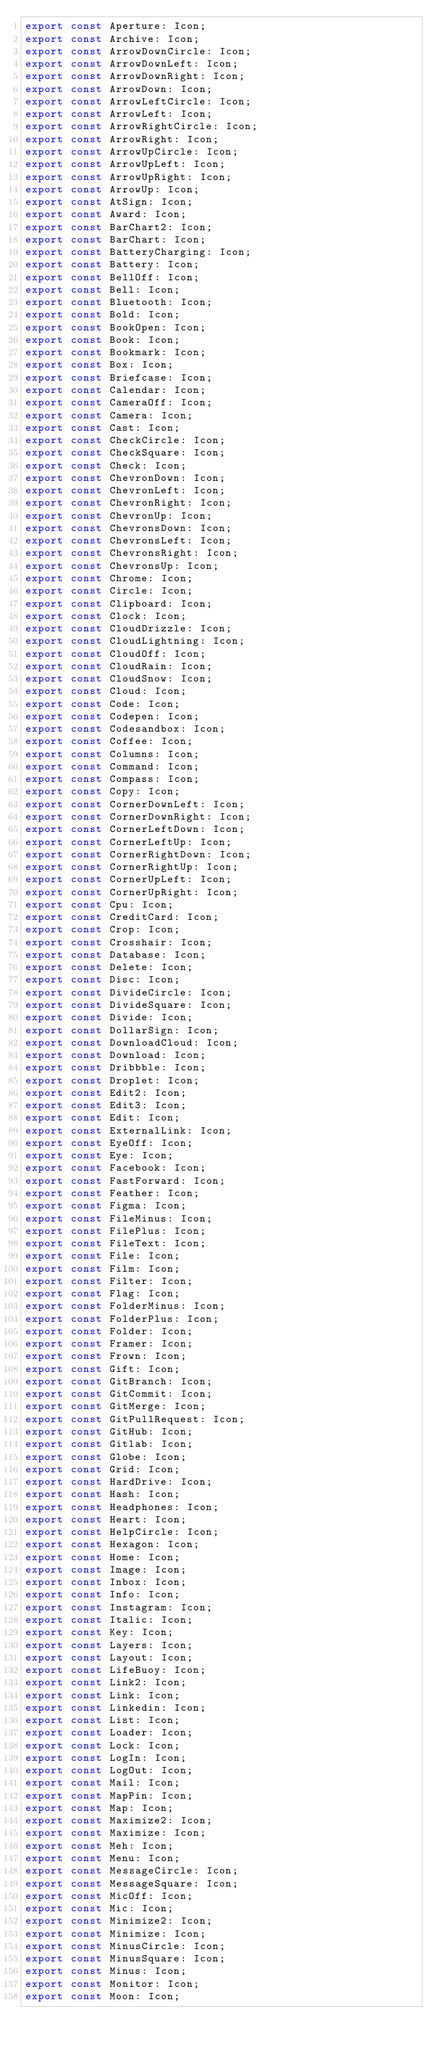<code> <loc_0><loc_0><loc_500><loc_500><_TypeScript_>export const Aperture: Icon;
export const Archive: Icon;
export const ArrowDownCircle: Icon;
export const ArrowDownLeft: Icon;
export const ArrowDownRight: Icon;
export const ArrowDown: Icon;
export const ArrowLeftCircle: Icon;
export const ArrowLeft: Icon;
export const ArrowRightCircle: Icon;
export const ArrowRight: Icon;
export const ArrowUpCircle: Icon;
export const ArrowUpLeft: Icon;
export const ArrowUpRight: Icon;
export const ArrowUp: Icon;
export const AtSign: Icon;
export const Award: Icon;
export const BarChart2: Icon;
export const BarChart: Icon;
export const BatteryCharging: Icon;
export const Battery: Icon;
export const BellOff: Icon;
export const Bell: Icon;
export const Bluetooth: Icon;
export const Bold: Icon;
export const BookOpen: Icon;
export const Book: Icon;
export const Bookmark: Icon;
export const Box: Icon;
export const Briefcase: Icon;
export const Calendar: Icon;
export const CameraOff: Icon;
export const Camera: Icon;
export const Cast: Icon;
export const CheckCircle: Icon;
export const CheckSquare: Icon;
export const Check: Icon;
export const ChevronDown: Icon;
export const ChevronLeft: Icon;
export const ChevronRight: Icon;
export const ChevronUp: Icon;
export const ChevronsDown: Icon;
export const ChevronsLeft: Icon;
export const ChevronsRight: Icon;
export const ChevronsUp: Icon;
export const Chrome: Icon;
export const Circle: Icon;
export const Clipboard: Icon;
export const Clock: Icon;
export const CloudDrizzle: Icon;
export const CloudLightning: Icon;
export const CloudOff: Icon;
export const CloudRain: Icon;
export const CloudSnow: Icon;
export const Cloud: Icon;
export const Code: Icon;
export const Codepen: Icon;
export const Codesandbox: Icon;
export const Coffee: Icon;
export const Columns: Icon;
export const Command: Icon;
export const Compass: Icon;
export const Copy: Icon;
export const CornerDownLeft: Icon;
export const CornerDownRight: Icon;
export const CornerLeftDown: Icon;
export const CornerLeftUp: Icon;
export const CornerRightDown: Icon;
export const CornerRightUp: Icon;
export const CornerUpLeft: Icon;
export const CornerUpRight: Icon;
export const Cpu: Icon;
export const CreditCard: Icon;
export const Crop: Icon;
export const Crosshair: Icon;
export const Database: Icon;
export const Delete: Icon;
export const Disc: Icon;
export const DivideCircle: Icon;
export const DivideSquare: Icon;
export const Divide: Icon;
export const DollarSign: Icon;
export const DownloadCloud: Icon;
export const Download: Icon;
export const Dribbble: Icon;
export const Droplet: Icon;
export const Edit2: Icon;
export const Edit3: Icon;
export const Edit: Icon;
export const ExternalLink: Icon;
export const EyeOff: Icon;
export const Eye: Icon;
export const Facebook: Icon;
export const FastForward: Icon;
export const Feather: Icon;
export const Figma: Icon;
export const FileMinus: Icon;
export const FilePlus: Icon;
export const FileText: Icon;
export const File: Icon;
export const Film: Icon;
export const Filter: Icon;
export const Flag: Icon;
export const FolderMinus: Icon;
export const FolderPlus: Icon;
export const Folder: Icon;
export const Framer: Icon;
export const Frown: Icon;
export const Gift: Icon;
export const GitBranch: Icon;
export const GitCommit: Icon;
export const GitMerge: Icon;
export const GitPullRequest: Icon;
export const GitHub: Icon;
export const Gitlab: Icon;
export const Globe: Icon;
export const Grid: Icon;
export const HardDrive: Icon;
export const Hash: Icon;
export const Headphones: Icon;
export const Heart: Icon;
export const HelpCircle: Icon;
export const Hexagon: Icon;
export const Home: Icon;
export const Image: Icon;
export const Inbox: Icon;
export const Info: Icon;
export const Instagram: Icon;
export const Italic: Icon;
export const Key: Icon;
export const Layers: Icon;
export const Layout: Icon;
export const LifeBuoy: Icon;
export const Link2: Icon;
export const Link: Icon;
export const Linkedin: Icon;
export const List: Icon;
export const Loader: Icon;
export const Lock: Icon;
export const LogIn: Icon;
export const LogOut: Icon;
export const Mail: Icon;
export const MapPin: Icon;
export const Map: Icon;
export const Maximize2: Icon;
export const Maximize: Icon;
export const Meh: Icon;
export const Menu: Icon;
export const MessageCircle: Icon;
export const MessageSquare: Icon;
export const MicOff: Icon;
export const Mic: Icon;
export const Minimize2: Icon;
export const Minimize: Icon;
export const MinusCircle: Icon;
export const MinusSquare: Icon;
export const Minus: Icon;
export const Monitor: Icon;
export const Moon: Icon;</code> 